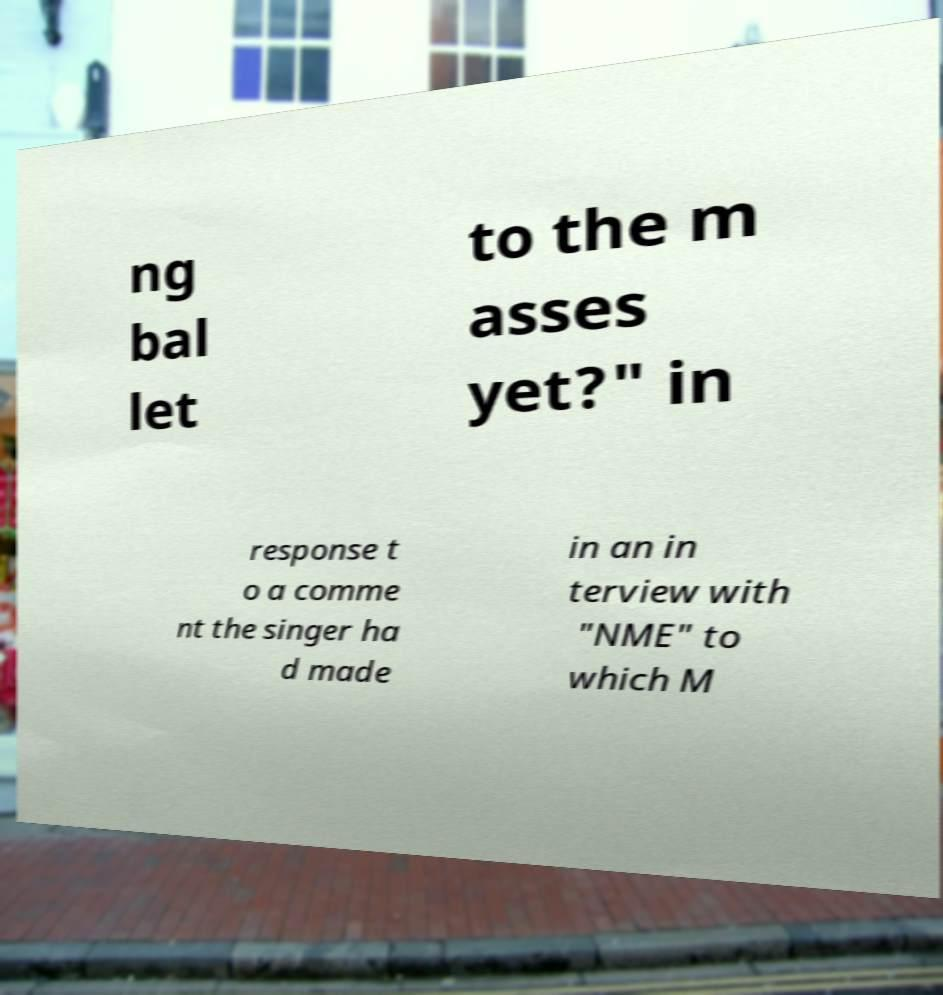I need the written content from this picture converted into text. Can you do that? ng bal let to the m asses yet?" in response t o a comme nt the singer ha d made in an in terview with "NME" to which M 